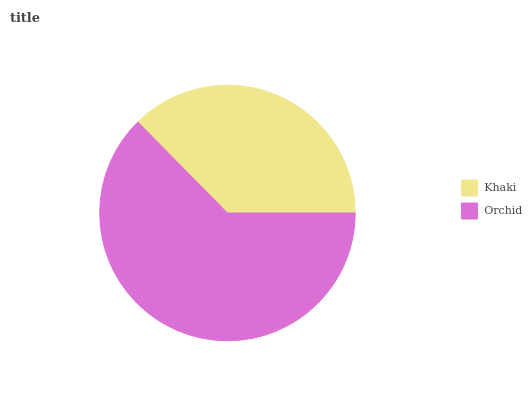Is Khaki the minimum?
Answer yes or no. Yes. Is Orchid the maximum?
Answer yes or no. Yes. Is Orchid the minimum?
Answer yes or no. No. Is Orchid greater than Khaki?
Answer yes or no. Yes. Is Khaki less than Orchid?
Answer yes or no. Yes. Is Khaki greater than Orchid?
Answer yes or no. No. Is Orchid less than Khaki?
Answer yes or no. No. Is Orchid the high median?
Answer yes or no. Yes. Is Khaki the low median?
Answer yes or no. Yes. Is Khaki the high median?
Answer yes or no. No. Is Orchid the low median?
Answer yes or no. No. 